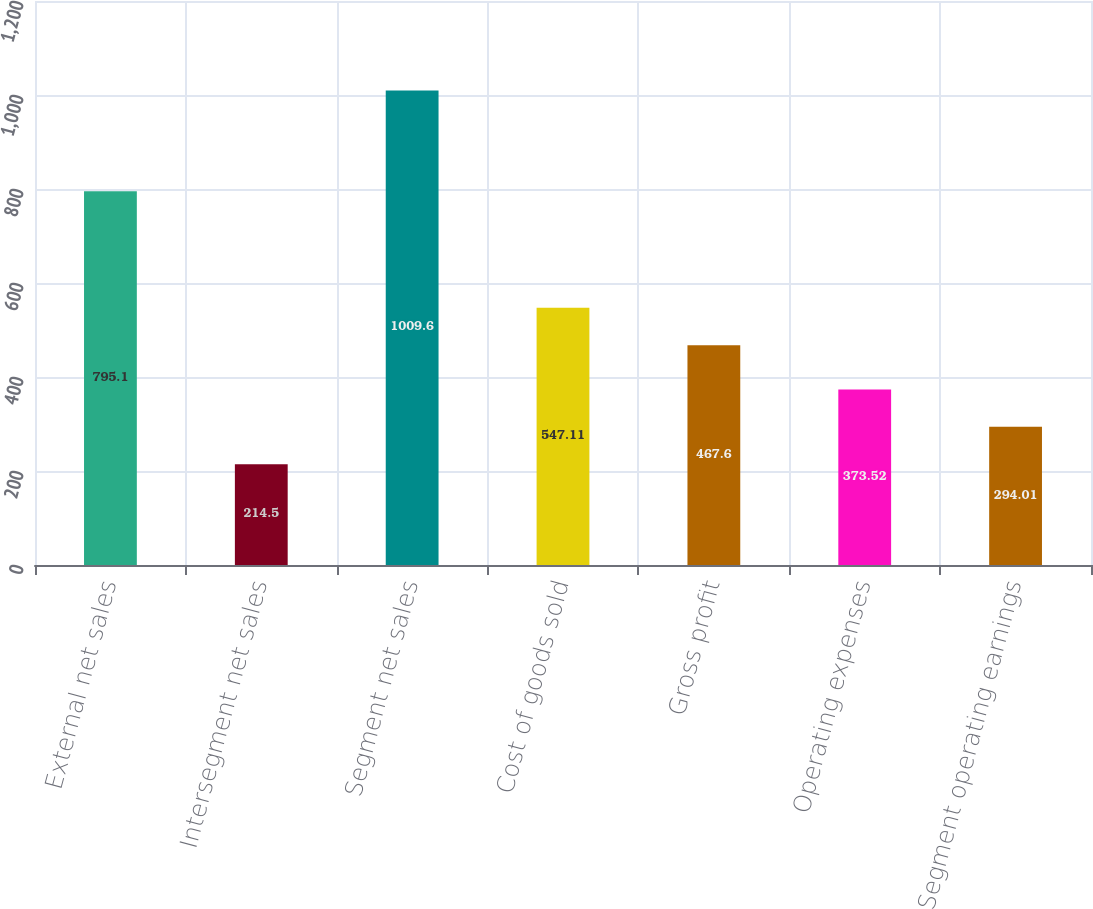Convert chart. <chart><loc_0><loc_0><loc_500><loc_500><bar_chart><fcel>External net sales<fcel>Intersegment net sales<fcel>Segment net sales<fcel>Cost of goods sold<fcel>Gross profit<fcel>Operating expenses<fcel>Segment operating earnings<nl><fcel>795.1<fcel>214.5<fcel>1009.6<fcel>547.11<fcel>467.6<fcel>373.52<fcel>294.01<nl></chart> 